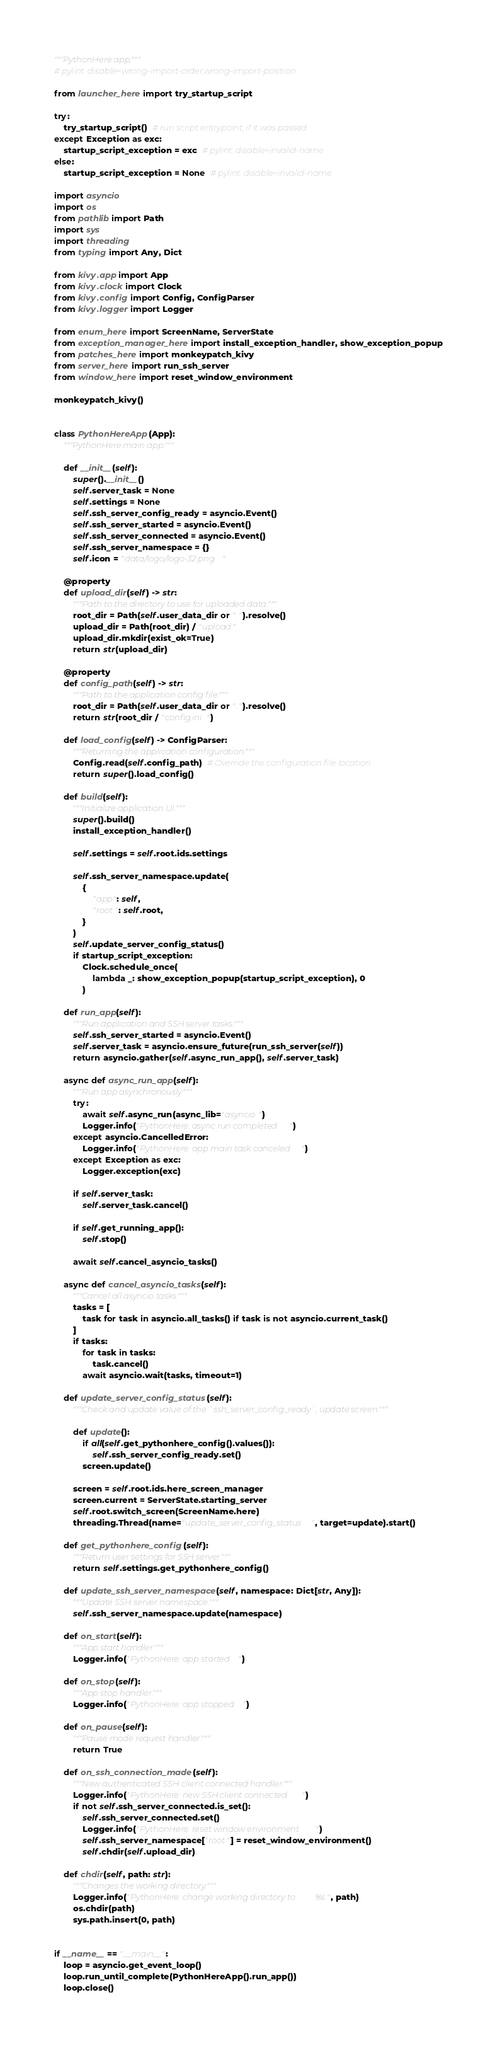Convert code to text. <code><loc_0><loc_0><loc_500><loc_500><_Python_>"""PythonHere app."""
# pylint: disable=wrong-import-order,wrong-import-position

from launcher_here import try_startup_script

try:
    try_startup_script()  # run script entrypoint, if it was passed
except Exception as exc:
    startup_script_exception = exc  # pylint: disable=invalid-name
else:
    startup_script_exception = None  # pylint: disable=invalid-name

import asyncio
import os
from pathlib import Path
import sys
import threading
from typing import Any, Dict

from kivy.app import App
from kivy.clock import Clock
from kivy.config import Config, ConfigParser
from kivy.logger import Logger

from enum_here import ScreenName, ServerState
from exception_manager_here import install_exception_handler, show_exception_popup
from patches_here import monkeypatch_kivy
from server_here import run_ssh_server
from window_here import reset_window_environment

monkeypatch_kivy()


class PythonHereApp(App):
    """PythonHere main app."""

    def __init__(self):
        super().__init__()
        self.server_task = None
        self.settings = None
        self.ssh_server_config_ready = asyncio.Event()
        self.ssh_server_started = asyncio.Event()
        self.ssh_server_connected = asyncio.Event()
        self.ssh_server_namespace = {}
        self.icon = "data/logo/logo-32.png"

    @property
    def upload_dir(self) -> str:
        """Path to the directory to use for uploaded data."""
        root_dir = Path(self.user_data_dir or ".").resolve()
        upload_dir = Path(root_dir) / "upload"
        upload_dir.mkdir(exist_ok=True)
        return str(upload_dir)

    @property
    def config_path(self) -> str:
        """Path to the application config file."""
        root_dir = Path(self.user_data_dir or ".").resolve()
        return str(root_dir / "config.ini")

    def load_config(self) -> ConfigParser:
        """Returning the application configuration."""
        Config.read(self.config_path)  # Override the configuration file location
        return super().load_config()

    def build(self):
        """Initialize application UI."""
        super().build()
        install_exception_handler()

        self.settings = self.root.ids.settings

        self.ssh_server_namespace.update(
            {
                "app": self,
                "root": self.root,
            }
        )
        self.update_server_config_status()
        if startup_script_exception:
            Clock.schedule_once(
                lambda _: show_exception_popup(startup_script_exception), 0
            )

    def run_app(self):
        """Run application and SSH server tasks."""
        self.ssh_server_started = asyncio.Event()
        self.server_task = asyncio.ensure_future(run_ssh_server(self))
        return asyncio.gather(self.async_run_app(), self.server_task)

    async def async_run_app(self):
        """Run app asynchronously."""
        try:
            await self.async_run(async_lib="asyncio")
            Logger.info("PythonHere: async run completed")
        except asyncio.CancelledError:
            Logger.info("PythonHere: app main task canceled")
        except Exception as exc:
            Logger.exception(exc)

        if self.server_task:
            self.server_task.cancel()

        if self.get_running_app():
            self.stop()

        await self.cancel_asyncio_tasks()

    async def cancel_asyncio_tasks(self):
        """Cancel all asyncio tasks."""
        tasks = [
            task for task in asyncio.all_tasks() if task is not asyncio.current_task()
        ]
        if tasks:
            for task in tasks:
                task.cancel()
            await asyncio.wait(tasks, timeout=1)

    def update_server_config_status(self):
        """Check and update value of the `ssh_server_config_ready`, update screen."""

        def update():
            if all(self.get_pythonhere_config().values()):
                self.ssh_server_config_ready.set()
            screen.update()

        screen = self.root.ids.here_screen_manager
        screen.current = ServerState.starting_server
        self.root.switch_screen(ScreenName.here)
        threading.Thread(name="update_server_config_status", target=update).start()

    def get_pythonhere_config(self):
        """Return user settings for SSH server."""
        return self.settings.get_pythonhere_config()

    def update_ssh_server_namespace(self, namespace: Dict[str, Any]):
        """Update SSH server namespace."""
        self.ssh_server_namespace.update(namespace)

    def on_start(self):
        """App start handler."""
        Logger.info("PythonHere: app started")

    def on_stop(self):
        """App stop handler."""
        Logger.info("PythonHere: app stopped")

    def on_pause(self):
        """Pause mode request handler."""
        return True

    def on_ssh_connection_made(self):
        """New authenticated SSH client connected handler."""
        Logger.info("PythonHere: new SSH client connected")
        if not self.ssh_server_connected.is_set():
            self.ssh_server_connected.set()
            Logger.info("PythonHere: reset window environment")
            self.ssh_server_namespace["root"] = reset_window_environment()
            self.chdir(self.upload_dir)

    def chdir(self, path: str):
        """Changes the working directory."""
        Logger.info("PythonHere: change working directory to %s", path)
        os.chdir(path)
        sys.path.insert(0, path)


if __name__ == "__main__":
    loop = asyncio.get_event_loop()
    loop.run_until_complete(PythonHereApp().run_app())
    loop.close()
</code> 